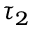Convert formula to latex. <formula><loc_0><loc_0><loc_500><loc_500>\tau _ { 2 }</formula> 